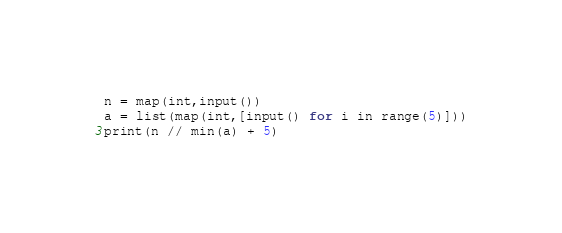<code> <loc_0><loc_0><loc_500><loc_500><_Python_>n = map(int,input())
a = list(map(int,[input() for i in range(5)]))
print(n // min(a) + 5) 
</code> 